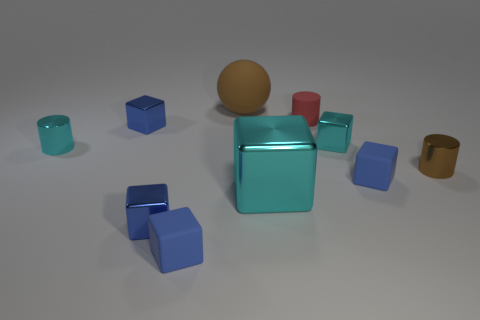How many blue cubes must be subtracted to get 1 blue cubes? 3 Subtract all cyan spheres. How many blue blocks are left? 4 Subtract 1 cubes. How many cubes are left? 5 Subtract all large shiny blocks. How many blocks are left? 5 Subtract all cyan blocks. How many blocks are left? 4 Subtract all purple cubes. Subtract all brown spheres. How many cubes are left? 6 Subtract all blocks. How many objects are left? 4 Subtract 0 gray cylinders. How many objects are left? 10 Subtract all tiny brown matte cylinders. Subtract all big brown spheres. How many objects are left? 9 Add 3 tiny cyan metallic objects. How many tiny cyan metallic objects are left? 5 